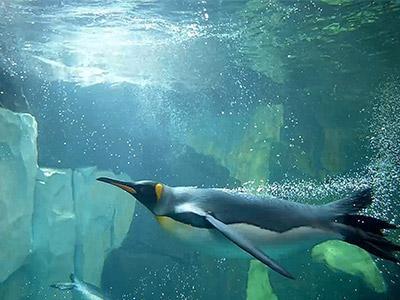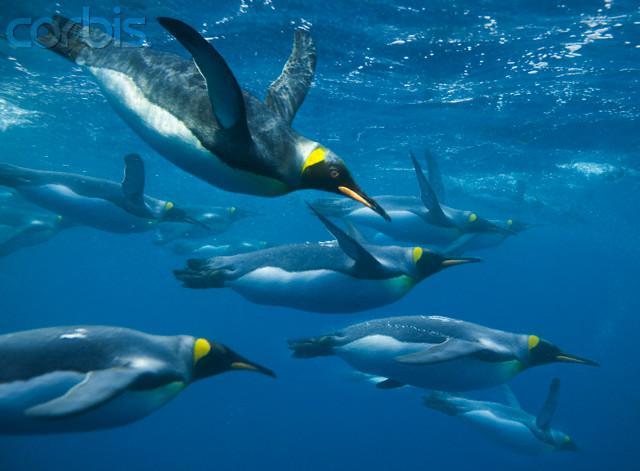The first image is the image on the left, the second image is the image on the right. For the images displayed, is the sentence "A single penguin is swimming to the left in one of the images." factually correct? Answer yes or no. Yes. 